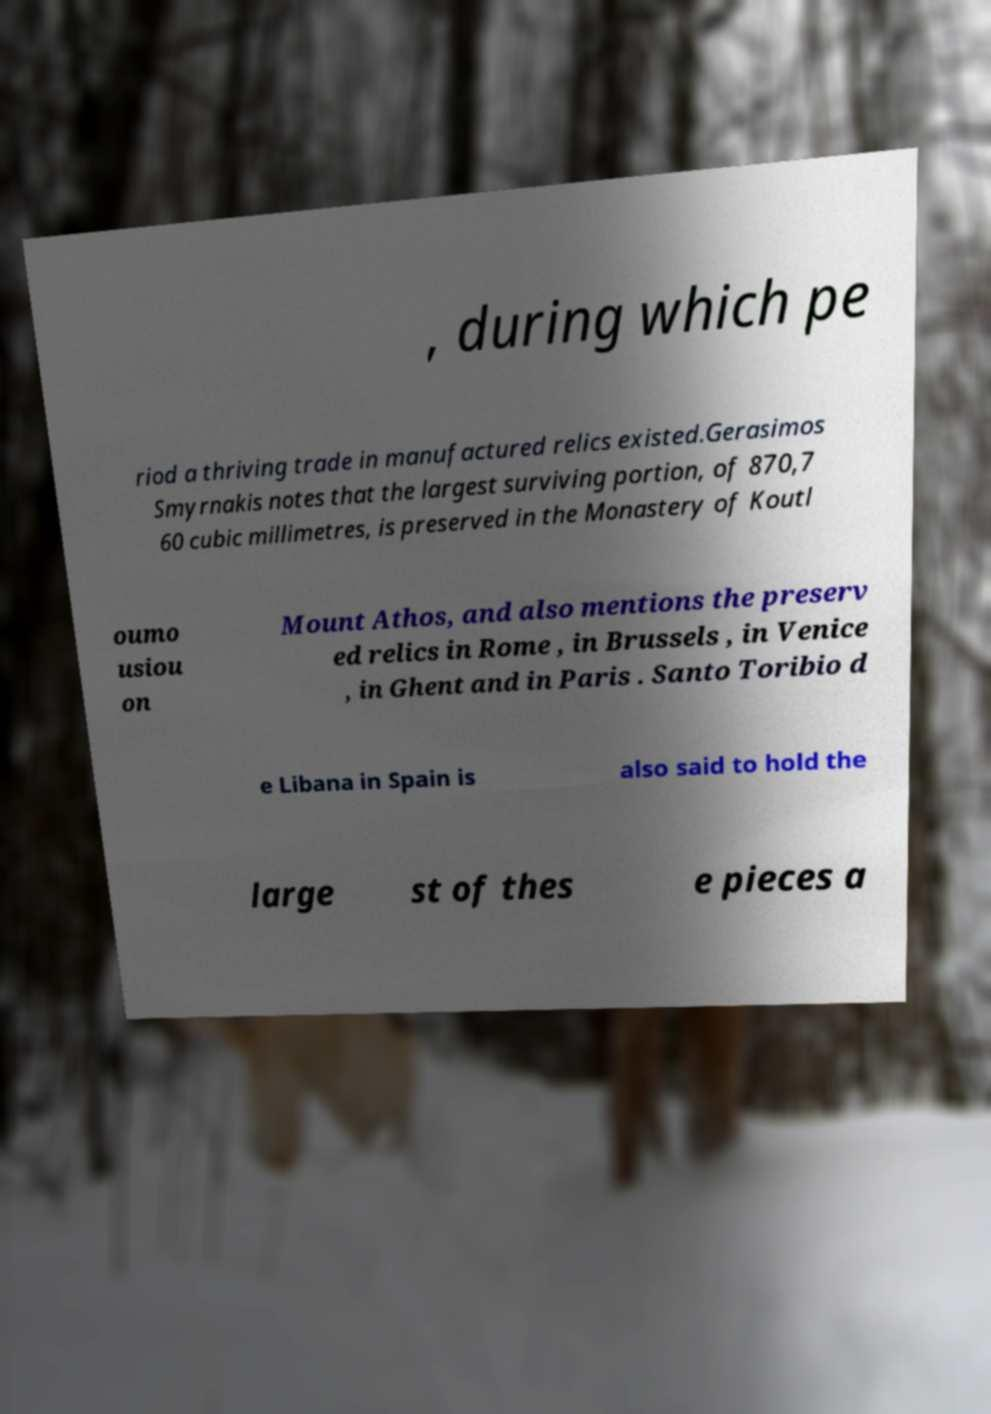There's text embedded in this image that I need extracted. Can you transcribe it verbatim? , during which pe riod a thriving trade in manufactured relics existed.Gerasimos Smyrnakis notes that the largest surviving portion, of 870,7 60 cubic millimetres, is preserved in the Monastery of Koutl oumo usiou on Mount Athos, and also mentions the preserv ed relics in Rome , in Brussels , in Venice , in Ghent and in Paris . Santo Toribio d e Libana in Spain is also said to hold the large st of thes e pieces a 